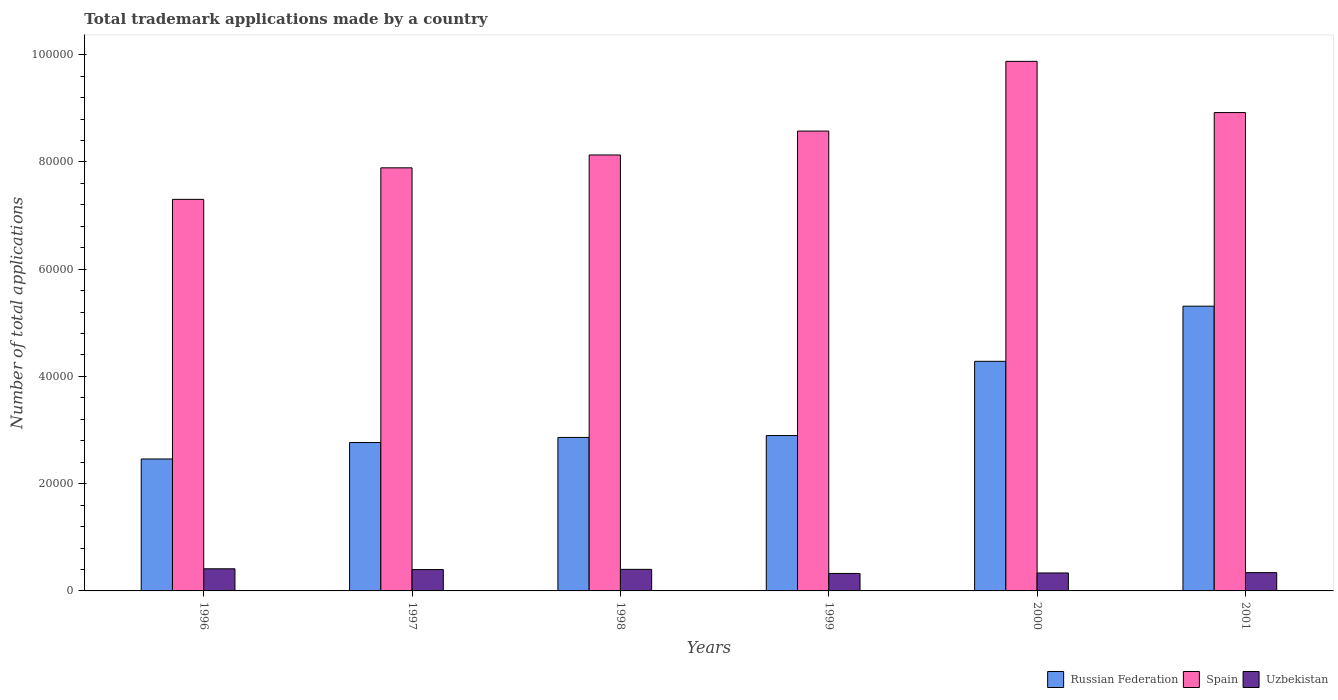Are the number of bars per tick equal to the number of legend labels?
Make the answer very short. Yes. Are the number of bars on each tick of the X-axis equal?
Your answer should be compact. Yes. How many bars are there on the 6th tick from the left?
Provide a short and direct response. 3. What is the number of applications made by in Russian Federation in 1998?
Provide a succinct answer. 2.86e+04. Across all years, what is the maximum number of applications made by in Spain?
Make the answer very short. 9.88e+04. Across all years, what is the minimum number of applications made by in Uzbekistan?
Give a very brief answer. 3258. In which year was the number of applications made by in Uzbekistan maximum?
Your response must be concise. 1996. In which year was the number of applications made by in Uzbekistan minimum?
Offer a very short reply. 1999. What is the total number of applications made by in Uzbekistan in the graph?
Keep it short and to the point. 2.22e+04. What is the difference between the number of applications made by in Russian Federation in 1998 and that in 1999?
Give a very brief answer. -354. What is the difference between the number of applications made by in Russian Federation in 2000 and the number of applications made by in Uzbekistan in 1997?
Give a very brief answer. 3.88e+04. What is the average number of applications made by in Uzbekistan per year?
Provide a short and direct response. 3691.83. In the year 1999, what is the difference between the number of applications made by in Russian Federation and number of applications made by in Spain?
Your answer should be compact. -5.68e+04. What is the ratio of the number of applications made by in Russian Federation in 1997 to that in 1998?
Ensure brevity in your answer.  0.97. What is the difference between the highest and the second highest number of applications made by in Russian Federation?
Your answer should be compact. 1.03e+04. What is the difference between the highest and the lowest number of applications made by in Russian Federation?
Offer a very short reply. 2.85e+04. In how many years, is the number of applications made by in Russian Federation greater than the average number of applications made by in Russian Federation taken over all years?
Your response must be concise. 2. Is the sum of the number of applications made by in Russian Federation in 1996 and 1997 greater than the maximum number of applications made by in Uzbekistan across all years?
Your answer should be compact. Yes. What does the 1st bar from the right in 1997 represents?
Give a very brief answer. Uzbekistan. How many years are there in the graph?
Offer a very short reply. 6. What is the difference between two consecutive major ticks on the Y-axis?
Your response must be concise. 2.00e+04. Are the values on the major ticks of Y-axis written in scientific E-notation?
Keep it short and to the point. No. Where does the legend appear in the graph?
Offer a terse response. Bottom right. How are the legend labels stacked?
Ensure brevity in your answer.  Horizontal. What is the title of the graph?
Your response must be concise. Total trademark applications made by a country. What is the label or title of the Y-axis?
Provide a succinct answer. Number of total applications. What is the Number of total applications of Russian Federation in 1996?
Make the answer very short. 2.46e+04. What is the Number of total applications in Spain in 1996?
Provide a succinct answer. 7.30e+04. What is the Number of total applications in Uzbekistan in 1996?
Provide a succinct answer. 4128. What is the Number of total applications of Russian Federation in 1997?
Offer a terse response. 2.77e+04. What is the Number of total applications in Spain in 1997?
Offer a terse response. 7.89e+04. What is the Number of total applications of Uzbekistan in 1997?
Your answer should be very brief. 3982. What is the Number of total applications in Russian Federation in 1998?
Give a very brief answer. 2.86e+04. What is the Number of total applications of Spain in 1998?
Offer a terse response. 8.13e+04. What is the Number of total applications in Uzbekistan in 1998?
Offer a very short reply. 4022. What is the Number of total applications in Russian Federation in 1999?
Your answer should be very brief. 2.90e+04. What is the Number of total applications in Spain in 1999?
Offer a terse response. 8.58e+04. What is the Number of total applications in Uzbekistan in 1999?
Offer a terse response. 3258. What is the Number of total applications in Russian Federation in 2000?
Offer a very short reply. 4.28e+04. What is the Number of total applications in Spain in 2000?
Offer a very short reply. 9.88e+04. What is the Number of total applications of Uzbekistan in 2000?
Provide a succinct answer. 3348. What is the Number of total applications in Russian Federation in 2001?
Keep it short and to the point. 5.31e+04. What is the Number of total applications of Spain in 2001?
Keep it short and to the point. 8.92e+04. What is the Number of total applications of Uzbekistan in 2001?
Offer a very short reply. 3413. Across all years, what is the maximum Number of total applications of Russian Federation?
Make the answer very short. 5.31e+04. Across all years, what is the maximum Number of total applications of Spain?
Your answer should be very brief. 9.88e+04. Across all years, what is the maximum Number of total applications of Uzbekistan?
Your answer should be very brief. 4128. Across all years, what is the minimum Number of total applications of Russian Federation?
Give a very brief answer. 2.46e+04. Across all years, what is the minimum Number of total applications in Spain?
Ensure brevity in your answer.  7.30e+04. Across all years, what is the minimum Number of total applications of Uzbekistan?
Your response must be concise. 3258. What is the total Number of total applications of Russian Federation in the graph?
Keep it short and to the point. 2.06e+05. What is the total Number of total applications of Spain in the graph?
Ensure brevity in your answer.  5.07e+05. What is the total Number of total applications in Uzbekistan in the graph?
Provide a short and direct response. 2.22e+04. What is the difference between the Number of total applications in Russian Federation in 1996 and that in 1997?
Provide a short and direct response. -3069. What is the difference between the Number of total applications of Spain in 1996 and that in 1997?
Make the answer very short. -5879. What is the difference between the Number of total applications of Uzbekistan in 1996 and that in 1997?
Give a very brief answer. 146. What is the difference between the Number of total applications in Russian Federation in 1996 and that in 1998?
Offer a very short reply. -4016. What is the difference between the Number of total applications in Spain in 1996 and that in 1998?
Your answer should be compact. -8278. What is the difference between the Number of total applications of Uzbekistan in 1996 and that in 1998?
Your answer should be very brief. 106. What is the difference between the Number of total applications of Russian Federation in 1996 and that in 1999?
Your answer should be compact. -4370. What is the difference between the Number of total applications in Spain in 1996 and that in 1999?
Your answer should be compact. -1.27e+04. What is the difference between the Number of total applications of Uzbekistan in 1996 and that in 1999?
Ensure brevity in your answer.  870. What is the difference between the Number of total applications of Russian Federation in 1996 and that in 2000?
Ensure brevity in your answer.  -1.82e+04. What is the difference between the Number of total applications in Spain in 1996 and that in 2000?
Keep it short and to the point. -2.57e+04. What is the difference between the Number of total applications in Uzbekistan in 1996 and that in 2000?
Provide a succinct answer. 780. What is the difference between the Number of total applications of Russian Federation in 1996 and that in 2001?
Your answer should be very brief. -2.85e+04. What is the difference between the Number of total applications of Spain in 1996 and that in 2001?
Your answer should be very brief. -1.62e+04. What is the difference between the Number of total applications of Uzbekistan in 1996 and that in 2001?
Make the answer very short. 715. What is the difference between the Number of total applications of Russian Federation in 1997 and that in 1998?
Ensure brevity in your answer.  -947. What is the difference between the Number of total applications in Spain in 1997 and that in 1998?
Make the answer very short. -2399. What is the difference between the Number of total applications in Russian Federation in 1997 and that in 1999?
Give a very brief answer. -1301. What is the difference between the Number of total applications of Spain in 1997 and that in 1999?
Make the answer very short. -6858. What is the difference between the Number of total applications in Uzbekistan in 1997 and that in 1999?
Give a very brief answer. 724. What is the difference between the Number of total applications in Russian Federation in 1997 and that in 2000?
Offer a very short reply. -1.51e+04. What is the difference between the Number of total applications of Spain in 1997 and that in 2000?
Your answer should be very brief. -1.99e+04. What is the difference between the Number of total applications of Uzbekistan in 1997 and that in 2000?
Give a very brief answer. 634. What is the difference between the Number of total applications in Russian Federation in 1997 and that in 2001?
Give a very brief answer. -2.54e+04. What is the difference between the Number of total applications of Spain in 1997 and that in 2001?
Offer a terse response. -1.03e+04. What is the difference between the Number of total applications in Uzbekistan in 1997 and that in 2001?
Make the answer very short. 569. What is the difference between the Number of total applications in Russian Federation in 1998 and that in 1999?
Keep it short and to the point. -354. What is the difference between the Number of total applications in Spain in 1998 and that in 1999?
Make the answer very short. -4459. What is the difference between the Number of total applications of Uzbekistan in 1998 and that in 1999?
Your answer should be very brief. 764. What is the difference between the Number of total applications of Russian Federation in 1998 and that in 2000?
Provide a short and direct response. -1.42e+04. What is the difference between the Number of total applications of Spain in 1998 and that in 2000?
Offer a terse response. -1.75e+04. What is the difference between the Number of total applications of Uzbekistan in 1998 and that in 2000?
Give a very brief answer. 674. What is the difference between the Number of total applications in Russian Federation in 1998 and that in 2001?
Give a very brief answer. -2.45e+04. What is the difference between the Number of total applications in Spain in 1998 and that in 2001?
Ensure brevity in your answer.  -7907. What is the difference between the Number of total applications in Uzbekistan in 1998 and that in 2001?
Provide a succinct answer. 609. What is the difference between the Number of total applications of Russian Federation in 1999 and that in 2000?
Give a very brief answer. -1.38e+04. What is the difference between the Number of total applications in Spain in 1999 and that in 2000?
Your response must be concise. -1.30e+04. What is the difference between the Number of total applications of Uzbekistan in 1999 and that in 2000?
Make the answer very short. -90. What is the difference between the Number of total applications in Russian Federation in 1999 and that in 2001?
Provide a succinct answer. -2.41e+04. What is the difference between the Number of total applications in Spain in 1999 and that in 2001?
Keep it short and to the point. -3448. What is the difference between the Number of total applications of Uzbekistan in 1999 and that in 2001?
Ensure brevity in your answer.  -155. What is the difference between the Number of total applications in Russian Federation in 2000 and that in 2001?
Your answer should be compact. -1.03e+04. What is the difference between the Number of total applications of Spain in 2000 and that in 2001?
Your answer should be very brief. 9551. What is the difference between the Number of total applications in Uzbekistan in 2000 and that in 2001?
Your response must be concise. -65. What is the difference between the Number of total applications in Russian Federation in 1996 and the Number of total applications in Spain in 1997?
Ensure brevity in your answer.  -5.43e+04. What is the difference between the Number of total applications of Russian Federation in 1996 and the Number of total applications of Uzbekistan in 1997?
Provide a short and direct response. 2.06e+04. What is the difference between the Number of total applications of Spain in 1996 and the Number of total applications of Uzbekistan in 1997?
Give a very brief answer. 6.90e+04. What is the difference between the Number of total applications in Russian Federation in 1996 and the Number of total applications in Spain in 1998?
Keep it short and to the point. -5.67e+04. What is the difference between the Number of total applications of Russian Federation in 1996 and the Number of total applications of Uzbekistan in 1998?
Provide a short and direct response. 2.06e+04. What is the difference between the Number of total applications in Spain in 1996 and the Number of total applications in Uzbekistan in 1998?
Provide a short and direct response. 6.90e+04. What is the difference between the Number of total applications in Russian Federation in 1996 and the Number of total applications in Spain in 1999?
Provide a short and direct response. -6.11e+04. What is the difference between the Number of total applications of Russian Federation in 1996 and the Number of total applications of Uzbekistan in 1999?
Your answer should be compact. 2.13e+04. What is the difference between the Number of total applications of Spain in 1996 and the Number of total applications of Uzbekistan in 1999?
Your response must be concise. 6.98e+04. What is the difference between the Number of total applications of Russian Federation in 1996 and the Number of total applications of Spain in 2000?
Your response must be concise. -7.41e+04. What is the difference between the Number of total applications in Russian Federation in 1996 and the Number of total applications in Uzbekistan in 2000?
Your response must be concise. 2.13e+04. What is the difference between the Number of total applications in Spain in 1996 and the Number of total applications in Uzbekistan in 2000?
Give a very brief answer. 6.97e+04. What is the difference between the Number of total applications of Russian Federation in 1996 and the Number of total applications of Spain in 2001?
Ensure brevity in your answer.  -6.46e+04. What is the difference between the Number of total applications of Russian Federation in 1996 and the Number of total applications of Uzbekistan in 2001?
Your answer should be very brief. 2.12e+04. What is the difference between the Number of total applications of Spain in 1996 and the Number of total applications of Uzbekistan in 2001?
Provide a succinct answer. 6.96e+04. What is the difference between the Number of total applications in Russian Federation in 1997 and the Number of total applications in Spain in 1998?
Offer a very short reply. -5.36e+04. What is the difference between the Number of total applications in Russian Federation in 1997 and the Number of total applications in Uzbekistan in 1998?
Keep it short and to the point. 2.36e+04. What is the difference between the Number of total applications of Spain in 1997 and the Number of total applications of Uzbekistan in 1998?
Your answer should be compact. 7.49e+04. What is the difference between the Number of total applications of Russian Federation in 1997 and the Number of total applications of Spain in 1999?
Make the answer very short. -5.81e+04. What is the difference between the Number of total applications of Russian Federation in 1997 and the Number of total applications of Uzbekistan in 1999?
Keep it short and to the point. 2.44e+04. What is the difference between the Number of total applications of Spain in 1997 and the Number of total applications of Uzbekistan in 1999?
Your answer should be very brief. 7.56e+04. What is the difference between the Number of total applications of Russian Federation in 1997 and the Number of total applications of Spain in 2000?
Provide a short and direct response. -7.11e+04. What is the difference between the Number of total applications in Russian Federation in 1997 and the Number of total applications in Uzbekistan in 2000?
Offer a terse response. 2.43e+04. What is the difference between the Number of total applications of Spain in 1997 and the Number of total applications of Uzbekistan in 2000?
Give a very brief answer. 7.55e+04. What is the difference between the Number of total applications of Russian Federation in 1997 and the Number of total applications of Spain in 2001?
Offer a very short reply. -6.15e+04. What is the difference between the Number of total applications of Russian Federation in 1997 and the Number of total applications of Uzbekistan in 2001?
Provide a short and direct response. 2.43e+04. What is the difference between the Number of total applications of Spain in 1997 and the Number of total applications of Uzbekistan in 2001?
Offer a terse response. 7.55e+04. What is the difference between the Number of total applications of Russian Federation in 1998 and the Number of total applications of Spain in 1999?
Offer a terse response. -5.71e+04. What is the difference between the Number of total applications of Russian Federation in 1998 and the Number of total applications of Uzbekistan in 1999?
Your answer should be very brief. 2.54e+04. What is the difference between the Number of total applications of Spain in 1998 and the Number of total applications of Uzbekistan in 1999?
Give a very brief answer. 7.80e+04. What is the difference between the Number of total applications of Russian Federation in 1998 and the Number of total applications of Spain in 2000?
Ensure brevity in your answer.  -7.01e+04. What is the difference between the Number of total applications of Russian Federation in 1998 and the Number of total applications of Uzbekistan in 2000?
Keep it short and to the point. 2.53e+04. What is the difference between the Number of total applications in Spain in 1998 and the Number of total applications in Uzbekistan in 2000?
Give a very brief answer. 7.79e+04. What is the difference between the Number of total applications in Russian Federation in 1998 and the Number of total applications in Spain in 2001?
Make the answer very short. -6.06e+04. What is the difference between the Number of total applications in Russian Federation in 1998 and the Number of total applications in Uzbekistan in 2001?
Your answer should be very brief. 2.52e+04. What is the difference between the Number of total applications in Spain in 1998 and the Number of total applications in Uzbekistan in 2001?
Provide a short and direct response. 7.79e+04. What is the difference between the Number of total applications of Russian Federation in 1999 and the Number of total applications of Spain in 2000?
Provide a succinct answer. -6.98e+04. What is the difference between the Number of total applications of Russian Federation in 1999 and the Number of total applications of Uzbekistan in 2000?
Your answer should be very brief. 2.56e+04. What is the difference between the Number of total applications of Spain in 1999 and the Number of total applications of Uzbekistan in 2000?
Your answer should be compact. 8.24e+04. What is the difference between the Number of total applications of Russian Federation in 1999 and the Number of total applications of Spain in 2001?
Keep it short and to the point. -6.02e+04. What is the difference between the Number of total applications of Russian Federation in 1999 and the Number of total applications of Uzbekistan in 2001?
Provide a short and direct response. 2.56e+04. What is the difference between the Number of total applications in Spain in 1999 and the Number of total applications in Uzbekistan in 2001?
Ensure brevity in your answer.  8.23e+04. What is the difference between the Number of total applications of Russian Federation in 2000 and the Number of total applications of Spain in 2001?
Provide a short and direct response. -4.64e+04. What is the difference between the Number of total applications of Russian Federation in 2000 and the Number of total applications of Uzbekistan in 2001?
Provide a short and direct response. 3.94e+04. What is the difference between the Number of total applications in Spain in 2000 and the Number of total applications in Uzbekistan in 2001?
Provide a succinct answer. 9.53e+04. What is the average Number of total applications of Russian Federation per year?
Your response must be concise. 3.43e+04. What is the average Number of total applications of Spain per year?
Your response must be concise. 8.45e+04. What is the average Number of total applications of Uzbekistan per year?
Your answer should be compact. 3691.83. In the year 1996, what is the difference between the Number of total applications in Russian Federation and Number of total applications in Spain?
Your answer should be very brief. -4.84e+04. In the year 1996, what is the difference between the Number of total applications in Russian Federation and Number of total applications in Uzbekistan?
Keep it short and to the point. 2.05e+04. In the year 1996, what is the difference between the Number of total applications in Spain and Number of total applications in Uzbekistan?
Offer a very short reply. 6.89e+04. In the year 1997, what is the difference between the Number of total applications of Russian Federation and Number of total applications of Spain?
Ensure brevity in your answer.  -5.12e+04. In the year 1997, what is the difference between the Number of total applications in Russian Federation and Number of total applications in Uzbekistan?
Give a very brief answer. 2.37e+04. In the year 1997, what is the difference between the Number of total applications of Spain and Number of total applications of Uzbekistan?
Your answer should be very brief. 7.49e+04. In the year 1998, what is the difference between the Number of total applications of Russian Federation and Number of total applications of Spain?
Your answer should be very brief. -5.27e+04. In the year 1998, what is the difference between the Number of total applications of Russian Federation and Number of total applications of Uzbekistan?
Give a very brief answer. 2.46e+04. In the year 1998, what is the difference between the Number of total applications in Spain and Number of total applications in Uzbekistan?
Make the answer very short. 7.73e+04. In the year 1999, what is the difference between the Number of total applications in Russian Federation and Number of total applications in Spain?
Provide a succinct answer. -5.68e+04. In the year 1999, what is the difference between the Number of total applications of Russian Federation and Number of total applications of Uzbekistan?
Keep it short and to the point. 2.57e+04. In the year 1999, what is the difference between the Number of total applications in Spain and Number of total applications in Uzbekistan?
Offer a terse response. 8.25e+04. In the year 2000, what is the difference between the Number of total applications in Russian Federation and Number of total applications in Spain?
Your response must be concise. -5.59e+04. In the year 2000, what is the difference between the Number of total applications of Russian Federation and Number of total applications of Uzbekistan?
Your response must be concise. 3.95e+04. In the year 2000, what is the difference between the Number of total applications of Spain and Number of total applications of Uzbekistan?
Give a very brief answer. 9.54e+04. In the year 2001, what is the difference between the Number of total applications in Russian Federation and Number of total applications in Spain?
Offer a very short reply. -3.61e+04. In the year 2001, what is the difference between the Number of total applications of Russian Federation and Number of total applications of Uzbekistan?
Keep it short and to the point. 4.97e+04. In the year 2001, what is the difference between the Number of total applications in Spain and Number of total applications in Uzbekistan?
Offer a terse response. 8.58e+04. What is the ratio of the Number of total applications in Russian Federation in 1996 to that in 1997?
Offer a very short reply. 0.89. What is the ratio of the Number of total applications in Spain in 1996 to that in 1997?
Your response must be concise. 0.93. What is the ratio of the Number of total applications of Uzbekistan in 1996 to that in 1997?
Offer a very short reply. 1.04. What is the ratio of the Number of total applications in Russian Federation in 1996 to that in 1998?
Your response must be concise. 0.86. What is the ratio of the Number of total applications of Spain in 1996 to that in 1998?
Your answer should be compact. 0.9. What is the ratio of the Number of total applications in Uzbekistan in 1996 to that in 1998?
Offer a very short reply. 1.03. What is the ratio of the Number of total applications of Russian Federation in 1996 to that in 1999?
Ensure brevity in your answer.  0.85. What is the ratio of the Number of total applications in Spain in 1996 to that in 1999?
Your answer should be very brief. 0.85. What is the ratio of the Number of total applications of Uzbekistan in 1996 to that in 1999?
Keep it short and to the point. 1.27. What is the ratio of the Number of total applications of Russian Federation in 1996 to that in 2000?
Offer a terse response. 0.57. What is the ratio of the Number of total applications in Spain in 1996 to that in 2000?
Give a very brief answer. 0.74. What is the ratio of the Number of total applications of Uzbekistan in 1996 to that in 2000?
Your answer should be very brief. 1.23. What is the ratio of the Number of total applications of Russian Federation in 1996 to that in 2001?
Give a very brief answer. 0.46. What is the ratio of the Number of total applications in Spain in 1996 to that in 2001?
Provide a short and direct response. 0.82. What is the ratio of the Number of total applications in Uzbekistan in 1996 to that in 2001?
Provide a succinct answer. 1.21. What is the ratio of the Number of total applications of Russian Federation in 1997 to that in 1998?
Offer a terse response. 0.97. What is the ratio of the Number of total applications of Spain in 1997 to that in 1998?
Your response must be concise. 0.97. What is the ratio of the Number of total applications in Russian Federation in 1997 to that in 1999?
Make the answer very short. 0.96. What is the ratio of the Number of total applications of Uzbekistan in 1997 to that in 1999?
Your answer should be very brief. 1.22. What is the ratio of the Number of total applications of Russian Federation in 1997 to that in 2000?
Give a very brief answer. 0.65. What is the ratio of the Number of total applications in Spain in 1997 to that in 2000?
Offer a terse response. 0.8. What is the ratio of the Number of total applications of Uzbekistan in 1997 to that in 2000?
Offer a very short reply. 1.19. What is the ratio of the Number of total applications in Russian Federation in 1997 to that in 2001?
Your answer should be very brief. 0.52. What is the ratio of the Number of total applications of Spain in 1997 to that in 2001?
Offer a very short reply. 0.88. What is the ratio of the Number of total applications in Uzbekistan in 1997 to that in 2001?
Give a very brief answer. 1.17. What is the ratio of the Number of total applications of Russian Federation in 1998 to that in 1999?
Your answer should be compact. 0.99. What is the ratio of the Number of total applications of Spain in 1998 to that in 1999?
Offer a terse response. 0.95. What is the ratio of the Number of total applications in Uzbekistan in 1998 to that in 1999?
Make the answer very short. 1.23. What is the ratio of the Number of total applications of Russian Federation in 1998 to that in 2000?
Provide a short and direct response. 0.67. What is the ratio of the Number of total applications of Spain in 1998 to that in 2000?
Your response must be concise. 0.82. What is the ratio of the Number of total applications of Uzbekistan in 1998 to that in 2000?
Make the answer very short. 1.2. What is the ratio of the Number of total applications in Russian Federation in 1998 to that in 2001?
Provide a succinct answer. 0.54. What is the ratio of the Number of total applications in Spain in 1998 to that in 2001?
Give a very brief answer. 0.91. What is the ratio of the Number of total applications in Uzbekistan in 1998 to that in 2001?
Your response must be concise. 1.18. What is the ratio of the Number of total applications in Russian Federation in 1999 to that in 2000?
Provide a short and direct response. 0.68. What is the ratio of the Number of total applications of Spain in 1999 to that in 2000?
Your answer should be very brief. 0.87. What is the ratio of the Number of total applications in Uzbekistan in 1999 to that in 2000?
Ensure brevity in your answer.  0.97. What is the ratio of the Number of total applications in Russian Federation in 1999 to that in 2001?
Make the answer very short. 0.55. What is the ratio of the Number of total applications of Spain in 1999 to that in 2001?
Provide a succinct answer. 0.96. What is the ratio of the Number of total applications of Uzbekistan in 1999 to that in 2001?
Keep it short and to the point. 0.95. What is the ratio of the Number of total applications in Russian Federation in 2000 to that in 2001?
Your answer should be very brief. 0.81. What is the ratio of the Number of total applications of Spain in 2000 to that in 2001?
Ensure brevity in your answer.  1.11. What is the difference between the highest and the second highest Number of total applications of Russian Federation?
Your response must be concise. 1.03e+04. What is the difference between the highest and the second highest Number of total applications in Spain?
Ensure brevity in your answer.  9551. What is the difference between the highest and the second highest Number of total applications of Uzbekistan?
Your answer should be compact. 106. What is the difference between the highest and the lowest Number of total applications in Russian Federation?
Offer a terse response. 2.85e+04. What is the difference between the highest and the lowest Number of total applications of Spain?
Your answer should be very brief. 2.57e+04. What is the difference between the highest and the lowest Number of total applications in Uzbekistan?
Make the answer very short. 870. 